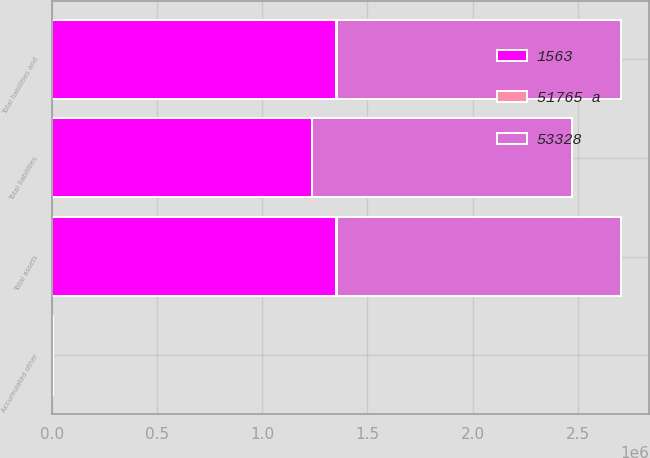Convert chart. <chart><loc_0><loc_0><loc_500><loc_500><stacked_bar_chart><ecel><fcel>Total assets<fcel>Total liabilities<fcel>Accumulated other<fcel>Total liabilities and<nl><fcel>53328<fcel>1.35308e+06<fcel>1.23619e+06<fcel>455<fcel>1.35308e+06<nl><fcel>51765 a<fcel>1563<fcel>461<fcel>1102<fcel>1563<nl><fcel>1563<fcel>1.35152e+06<fcel>1.23573e+06<fcel>1557<fcel>1.35152e+06<nl></chart> 